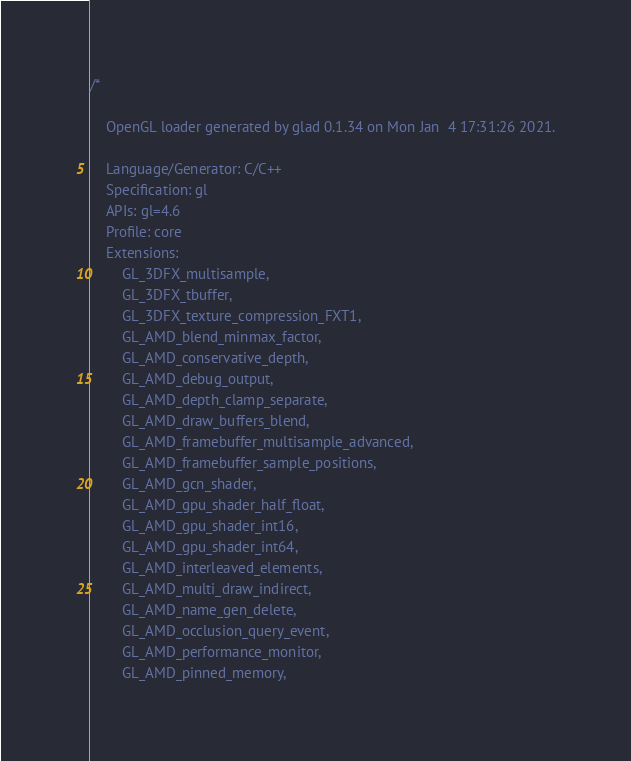<code> <loc_0><loc_0><loc_500><loc_500><_C_>/*

    OpenGL loader generated by glad 0.1.34 on Mon Jan  4 17:31:26 2021.

    Language/Generator: C/C++
    Specification: gl
    APIs: gl=4.6
    Profile: core
    Extensions:
        GL_3DFX_multisample,
        GL_3DFX_tbuffer,
        GL_3DFX_texture_compression_FXT1,
        GL_AMD_blend_minmax_factor,
        GL_AMD_conservative_depth,
        GL_AMD_debug_output,
        GL_AMD_depth_clamp_separate,
        GL_AMD_draw_buffers_blend,
        GL_AMD_framebuffer_multisample_advanced,
        GL_AMD_framebuffer_sample_positions,
        GL_AMD_gcn_shader,
        GL_AMD_gpu_shader_half_float,
        GL_AMD_gpu_shader_int16,
        GL_AMD_gpu_shader_int64,
        GL_AMD_interleaved_elements,
        GL_AMD_multi_draw_indirect,
        GL_AMD_name_gen_delete,
        GL_AMD_occlusion_query_event,
        GL_AMD_performance_monitor,
        GL_AMD_pinned_memory,</code> 